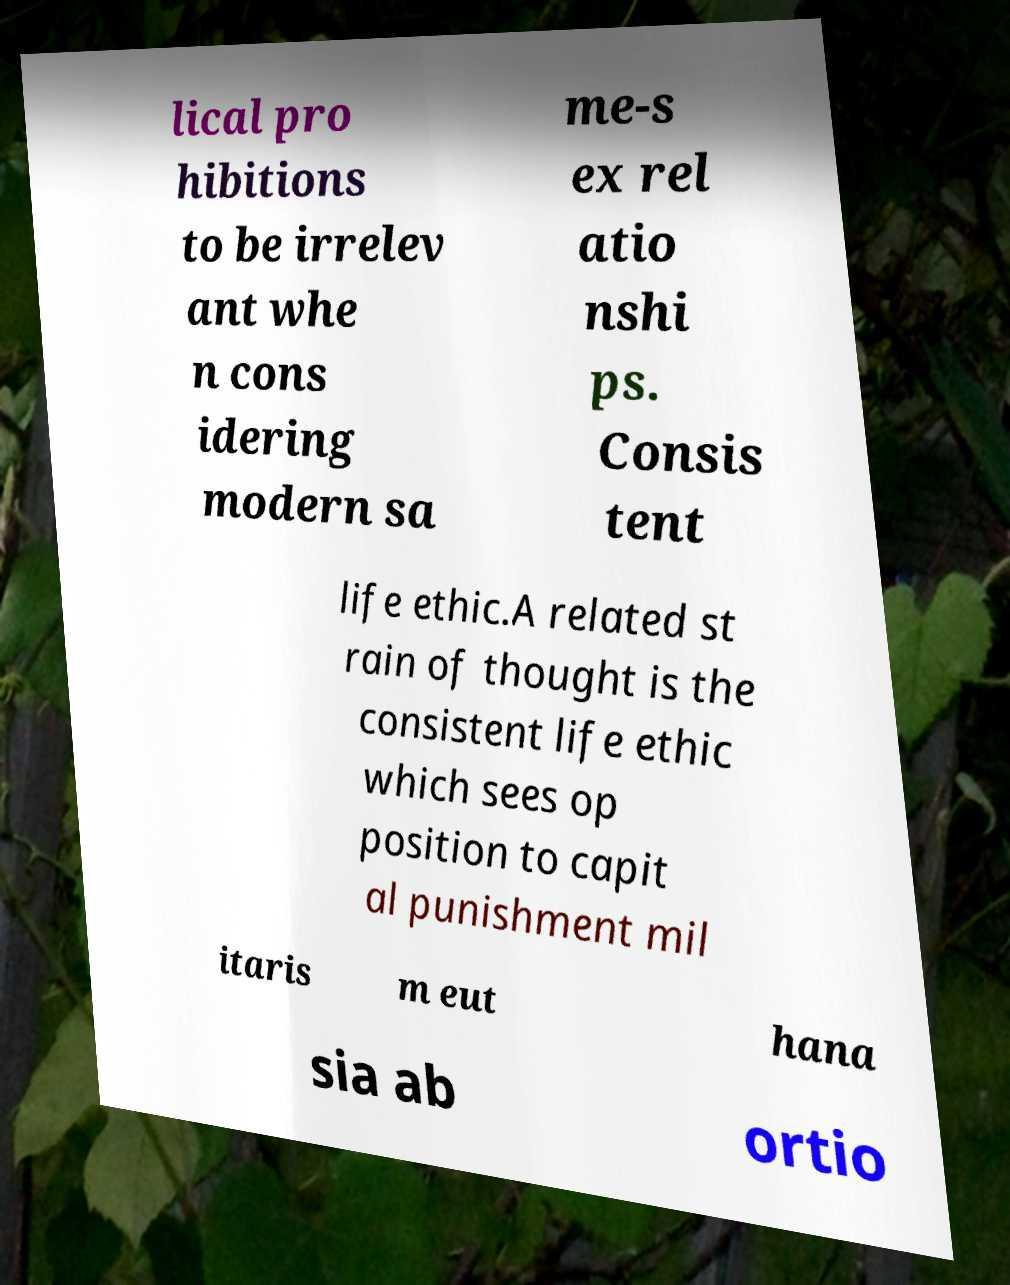Can you read and provide the text displayed in the image?This photo seems to have some interesting text. Can you extract and type it out for me? lical pro hibitions to be irrelev ant whe n cons idering modern sa me-s ex rel atio nshi ps. Consis tent life ethic.A related st rain of thought is the consistent life ethic which sees op position to capit al punishment mil itaris m eut hana sia ab ortio 